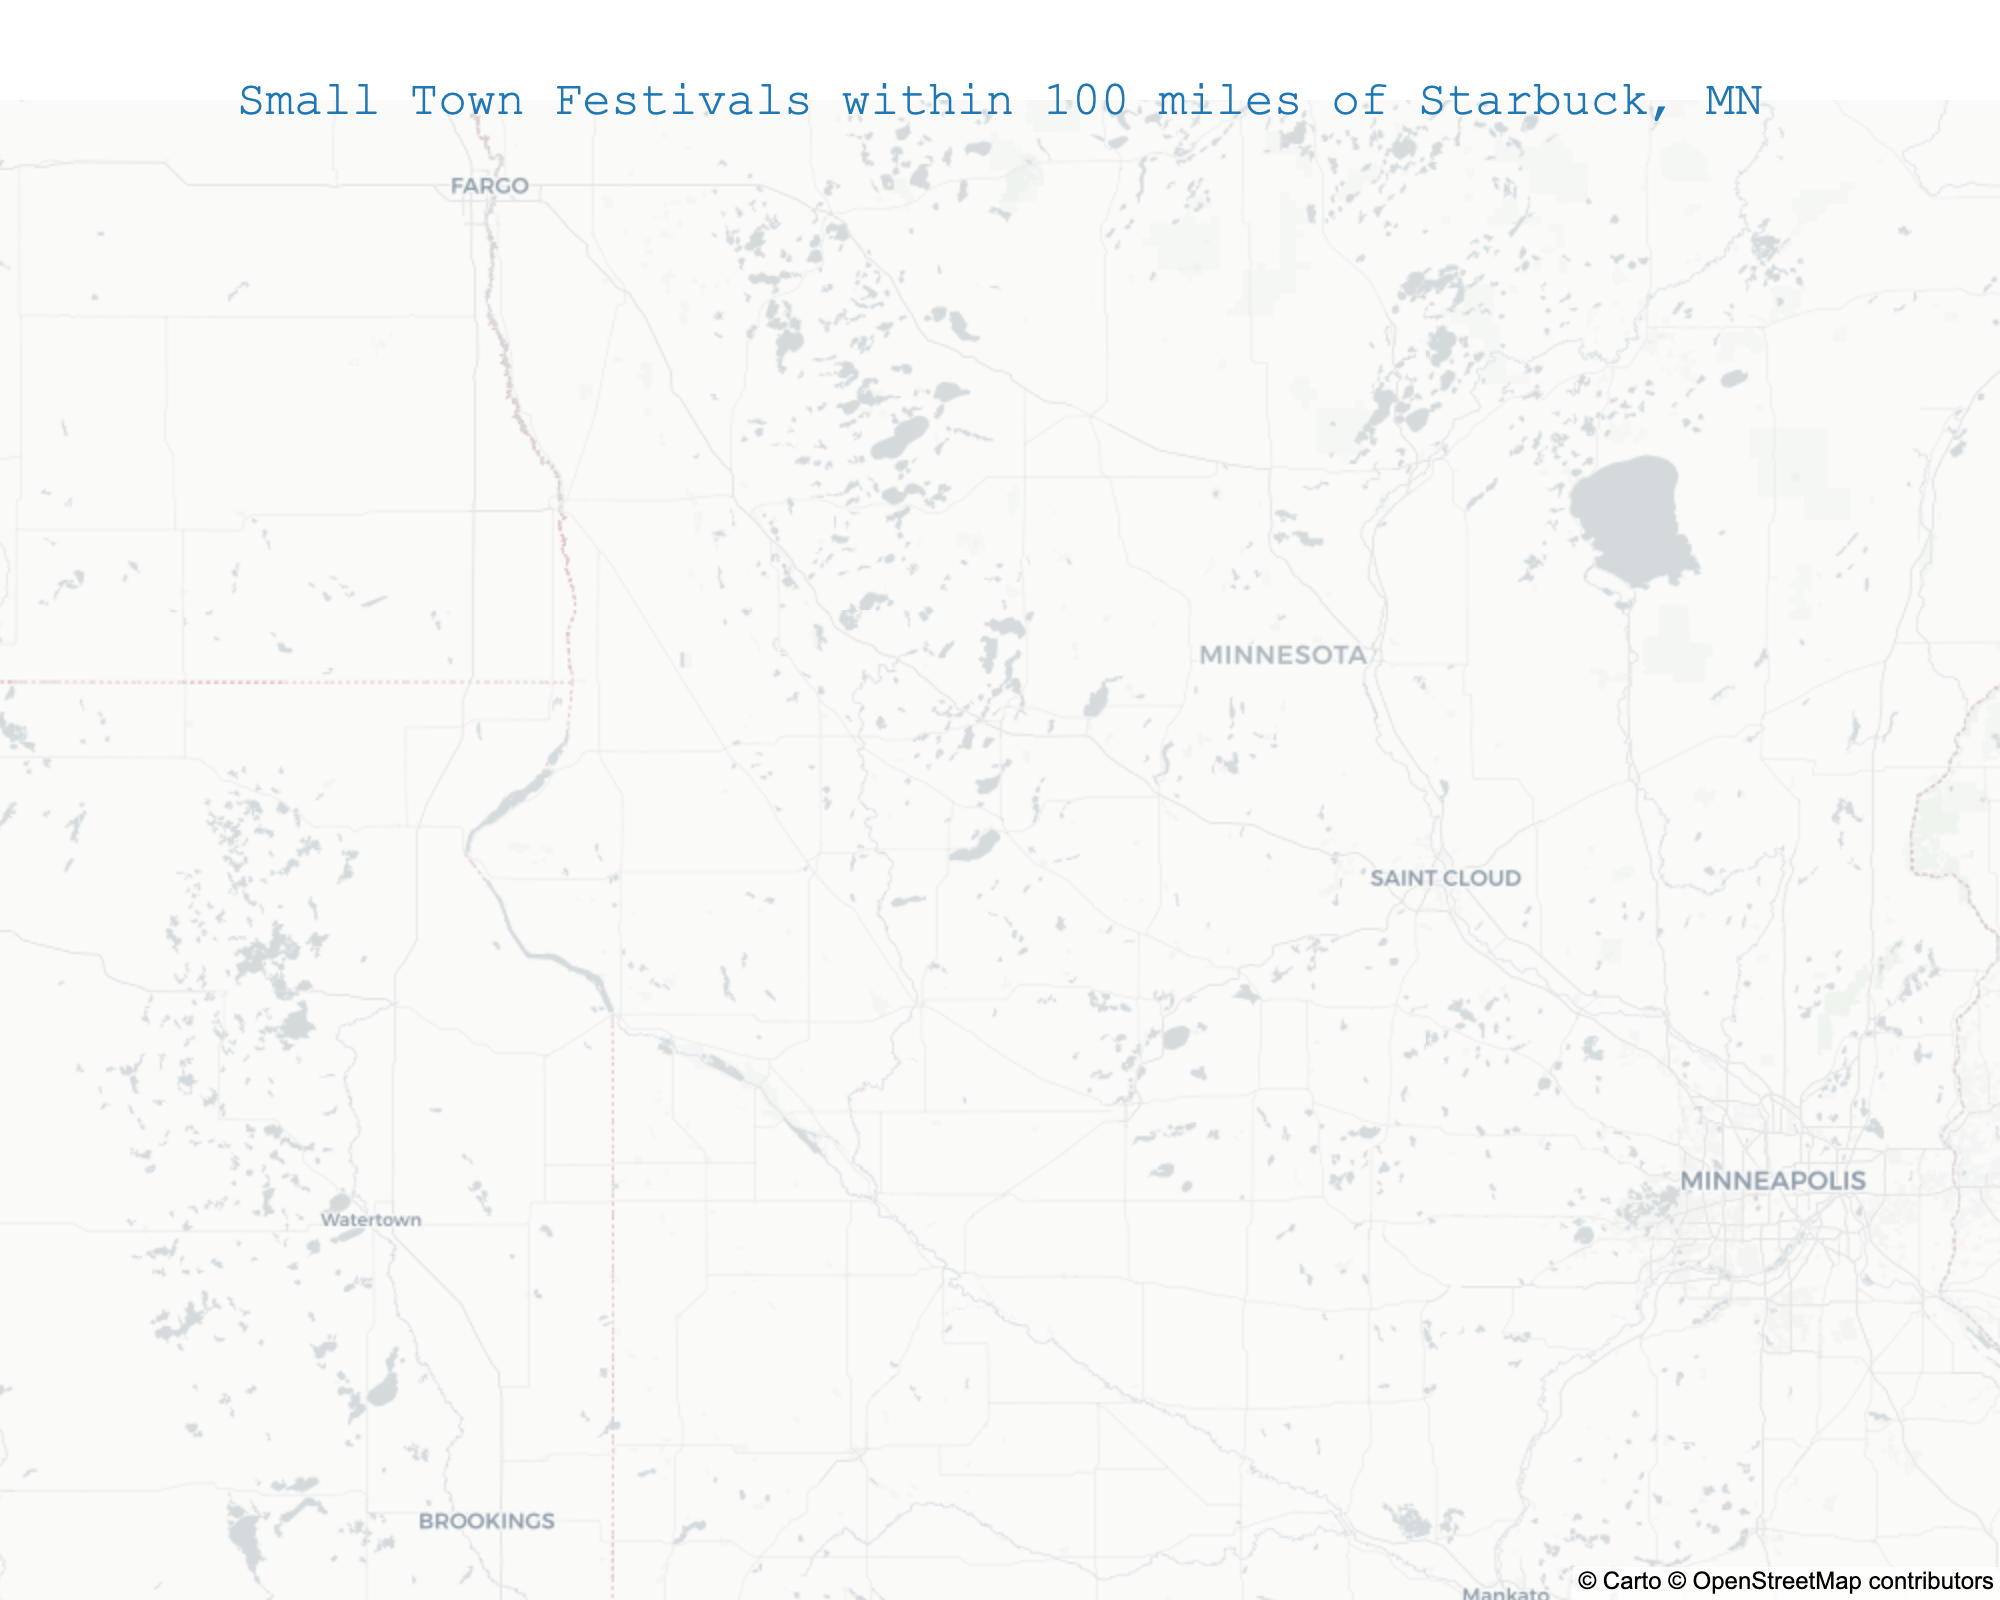What's the title of the figure? Look at the text positioned at the top center of the figure. It states the title directly.
Answer: Small Town Festivals within 100 miles of Starbuck, MN How many events are plotted on the map? Count the number of markers (stars) on the map representing different events.
Answer: 10 Which event is the northernmost on the map? Locate the marker placed at the highest latitude on the map, which is the most northern position.
Answer: Fergus Falls SummerFest Which event occurs earliest in the year? Check the dates associated with each event and find the one with the earliest date.
Answer: Fergus Falls SummerFest (June 11-13) Are there more events in July or August? Count the number of events taking place in July and August by checking the dates associated with each marker on the map.
Answer: August Which two events have the closest geographic proximity on the map? Locate the two markers that appear closest to each other geographically.
Answer: Pope County Fair and Glenwood Waterama What's the general direction of the Pelican Fest from Starbuck, MN? Look at the relative position of the Pelican Fest marker compared to Starbuck's center point (45.6155, -95.3897).
Answer: Northwest Which event is located at the westernmost point on the map? Find the marker located at the furthest longitude to the west.
Answer: Wheaton Old Settlers Reunion How many events are centered between latitudes 45.5 and 46? Count the number of markers that fall within the latitude range of 45.5 and 46.
Answer: 5 Which event has the shortest duration? Check the date range for each event and determine which has the smallest duration (number of days).
Answer: Benson Kid Day (1 day) 